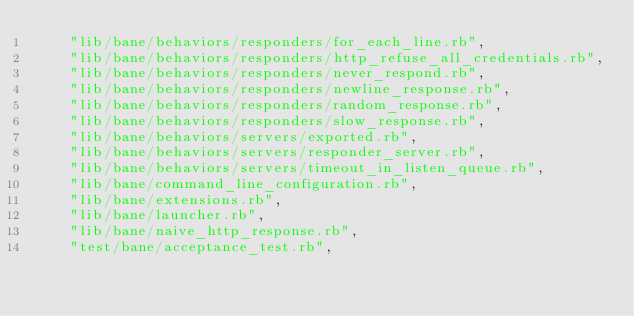<code> <loc_0><loc_0><loc_500><loc_500><_Ruby_>    "lib/bane/behaviors/responders/for_each_line.rb",
    "lib/bane/behaviors/responders/http_refuse_all_credentials.rb",
    "lib/bane/behaviors/responders/never_respond.rb",
    "lib/bane/behaviors/responders/newline_response.rb",
    "lib/bane/behaviors/responders/random_response.rb",
    "lib/bane/behaviors/responders/slow_response.rb",
    "lib/bane/behaviors/servers/exported.rb",
    "lib/bane/behaviors/servers/responder_server.rb",
    "lib/bane/behaviors/servers/timeout_in_listen_queue.rb",
    "lib/bane/command_line_configuration.rb",
    "lib/bane/extensions.rb",
    "lib/bane/launcher.rb",
    "lib/bane/naive_http_response.rb",
    "test/bane/acceptance_test.rb",</code> 